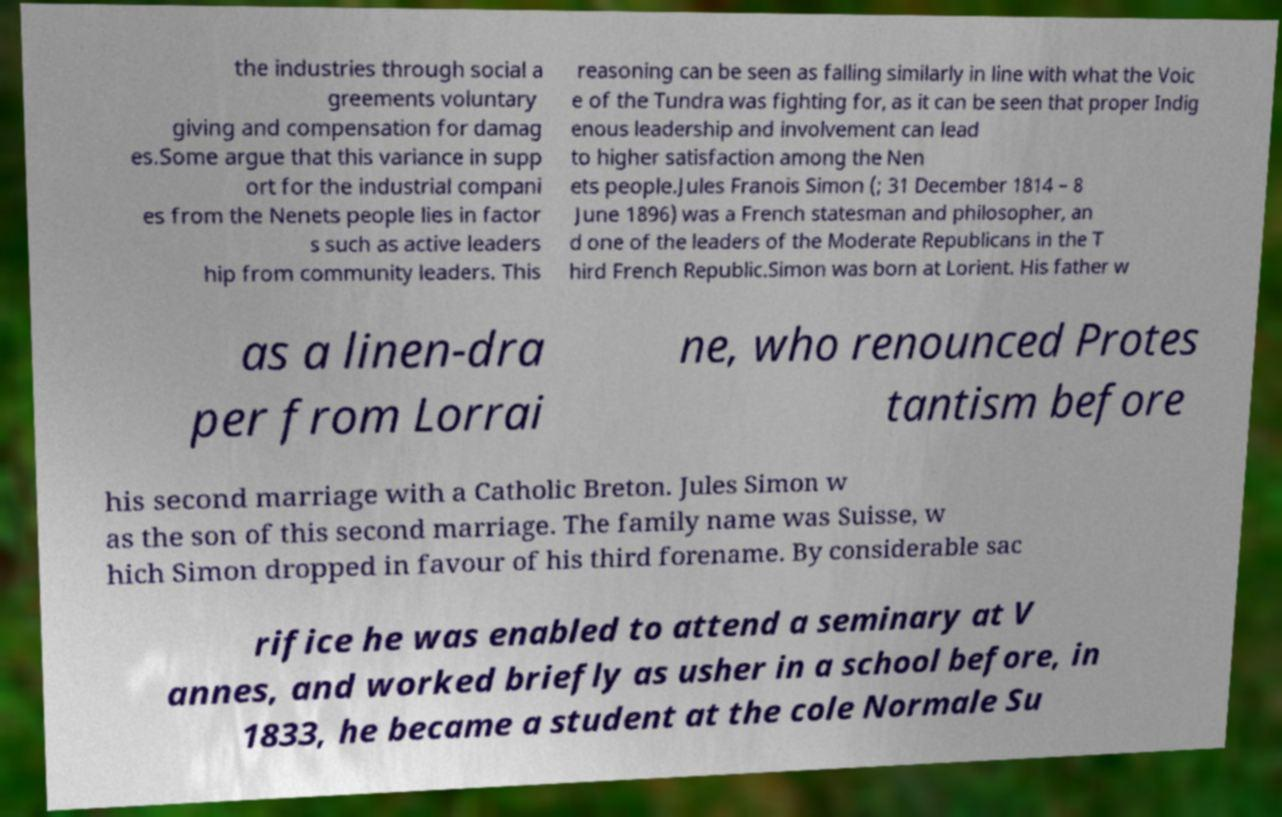Could you extract and type out the text from this image? the industries through social a greements voluntary giving and compensation for damag es.Some argue that this variance in supp ort for the industrial compani es from the Nenets people lies in factor s such as active leaders hip from community leaders. This reasoning can be seen as falling similarly in line with what the Voic e of the Tundra was fighting for, as it can be seen that proper Indig enous leadership and involvement can lead to higher satisfaction among the Nen ets people.Jules Franois Simon (; 31 December 1814 – 8 June 1896) was a French statesman and philosopher, an d one of the leaders of the Moderate Republicans in the T hird French Republic.Simon was born at Lorient. His father w as a linen-dra per from Lorrai ne, who renounced Protes tantism before his second marriage with a Catholic Breton. Jules Simon w as the son of this second marriage. The family name was Suisse, w hich Simon dropped in favour of his third forename. By considerable sac rifice he was enabled to attend a seminary at V annes, and worked briefly as usher in a school before, in 1833, he became a student at the cole Normale Su 